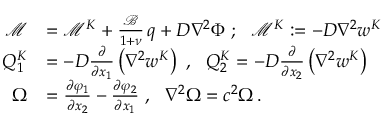Convert formula to latex. <formula><loc_0><loc_0><loc_500><loc_500>{ \begin{array} { r l } { { \mathcal { M } } } & { = { \mathcal { M } } ^ { K } + { \frac { \mathcal { B } } { 1 + \nu } } \, q + D \nabla ^ { 2 } \Phi ; { \mathcal { M } } ^ { K } \colon = - D \nabla ^ { 2 } w ^ { K } } \\ { Q _ { 1 } ^ { K } } & { = - D { \frac { \partial } { \partial x _ { 1 } } } \left ( \nabla ^ { 2 } w ^ { K } \right ) , Q _ { 2 } ^ { K } = - D { \frac { \partial } { \partial x _ { 2 } } } \left ( \nabla ^ { 2 } w ^ { K } \right ) } \\ { \Omega } & { = { \frac { \partial \varphi _ { 1 } } { \partial x _ { 2 } } } - { \frac { \partial \varphi _ { 2 } } { \partial x _ { 1 } } } , \nabla ^ { 2 } \Omega = c ^ { 2 } \Omega \, . } \end{array} }</formula> 